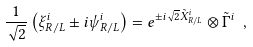Convert formula to latex. <formula><loc_0><loc_0><loc_500><loc_500>\frac { 1 } { \sqrt { 2 } } \left ( \xi _ { R / L } ^ { i } \pm i \psi _ { R / L } ^ { i } \right ) = e ^ { \pm i \sqrt { 2 } \tilde { X } _ { R / L } ^ { i } } \otimes \tilde { \Gamma } ^ { i } \ ,</formula> 